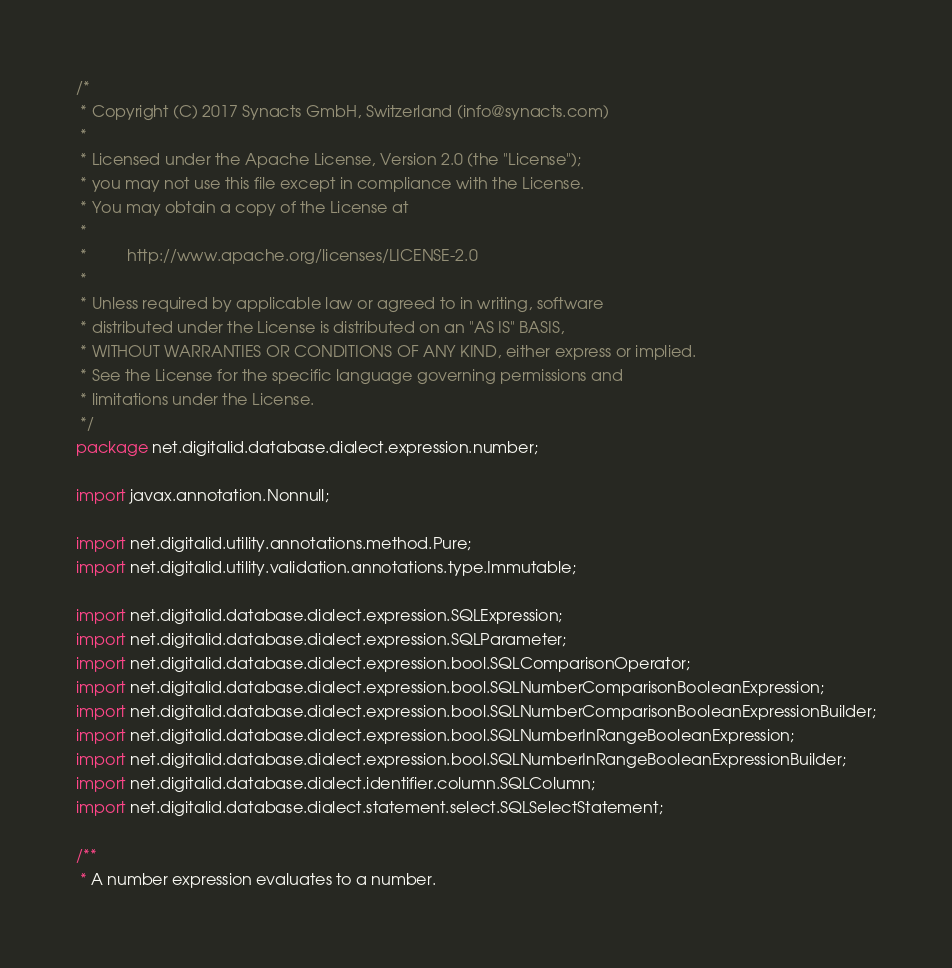Convert code to text. <code><loc_0><loc_0><loc_500><loc_500><_Java_>/*
 * Copyright (C) 2017 Synacts GmbH, Switzerland (info@synacts.com)
 *
 * Licensed under the Apache License, Version 2.0 (the "License");
 * you may not use this file except in compliance with the License.
 * You may obtain a copy of the License at
 *
 *         http://www.apache.org/licenses/LICENSE-2.0
 *
 * Unless required by applicable law or agreed to in writing, software
 * distributed under the License is distributed on an "AS IS" BASIS,
 * WITHOUT WARRANTIES OR CONDITIONS OF ANY KIND, either express or implied.
 * See the License for the specific language governing permissions and
 * limitations under the License.
 */
package net.digitalid.database.dialect.expression.number;

import javax.annotation.Nonnull;

import net.digitalid.utility.annotations.method.Pure;
import net.digitalid.utility.validation.annotations.type.Immutable;

import net.digitalid.database.dialect.expression.SQLExpression;
import net.digitalid.database.dialect.expression.SQLParameter;
import net.digitalid.database.dialect.expression.bool.SQLComparisonOperator;
import net.digitalid.database.dialect.expression.bool.SQLNumberComparisonBooleanExpression;
import net.digitalid.database.dialect.expression.bool.SQLNumberComparisonBooleanExpressionBuilder;
import net.digitalid.database.dialect.expression.bool.SQLNumberInRangeBooleanExpression;
import net.digitalid.database.dialect.expression.bool.SQLNumberInRangeBooleanExpressionBuilder;
import net.digitalid.database.dialect.identifier.column.SQLColumn;
import net.digitalid.database.dialect.statement.select.SQLSelectStatement;

/**
 * A number expression evaluates to a number.</code> 